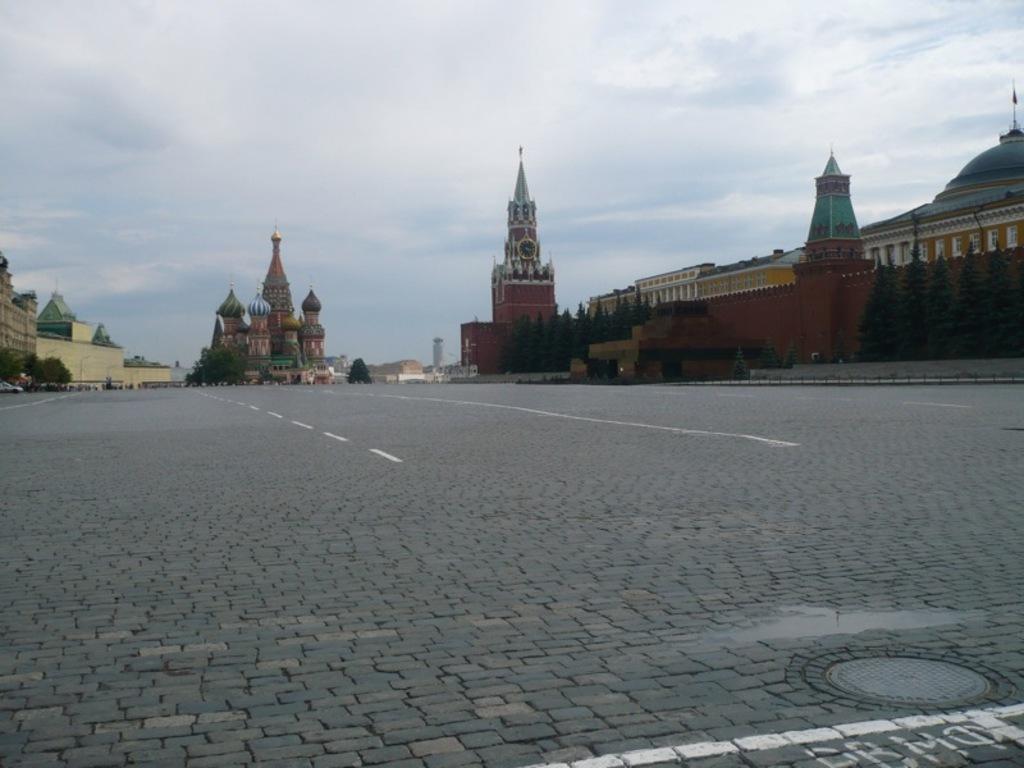How would you summarize this image in a sentence or two? There is a road, on which there are white color lines. In the background, there are buildings, trees and there are clouds in the sky. 